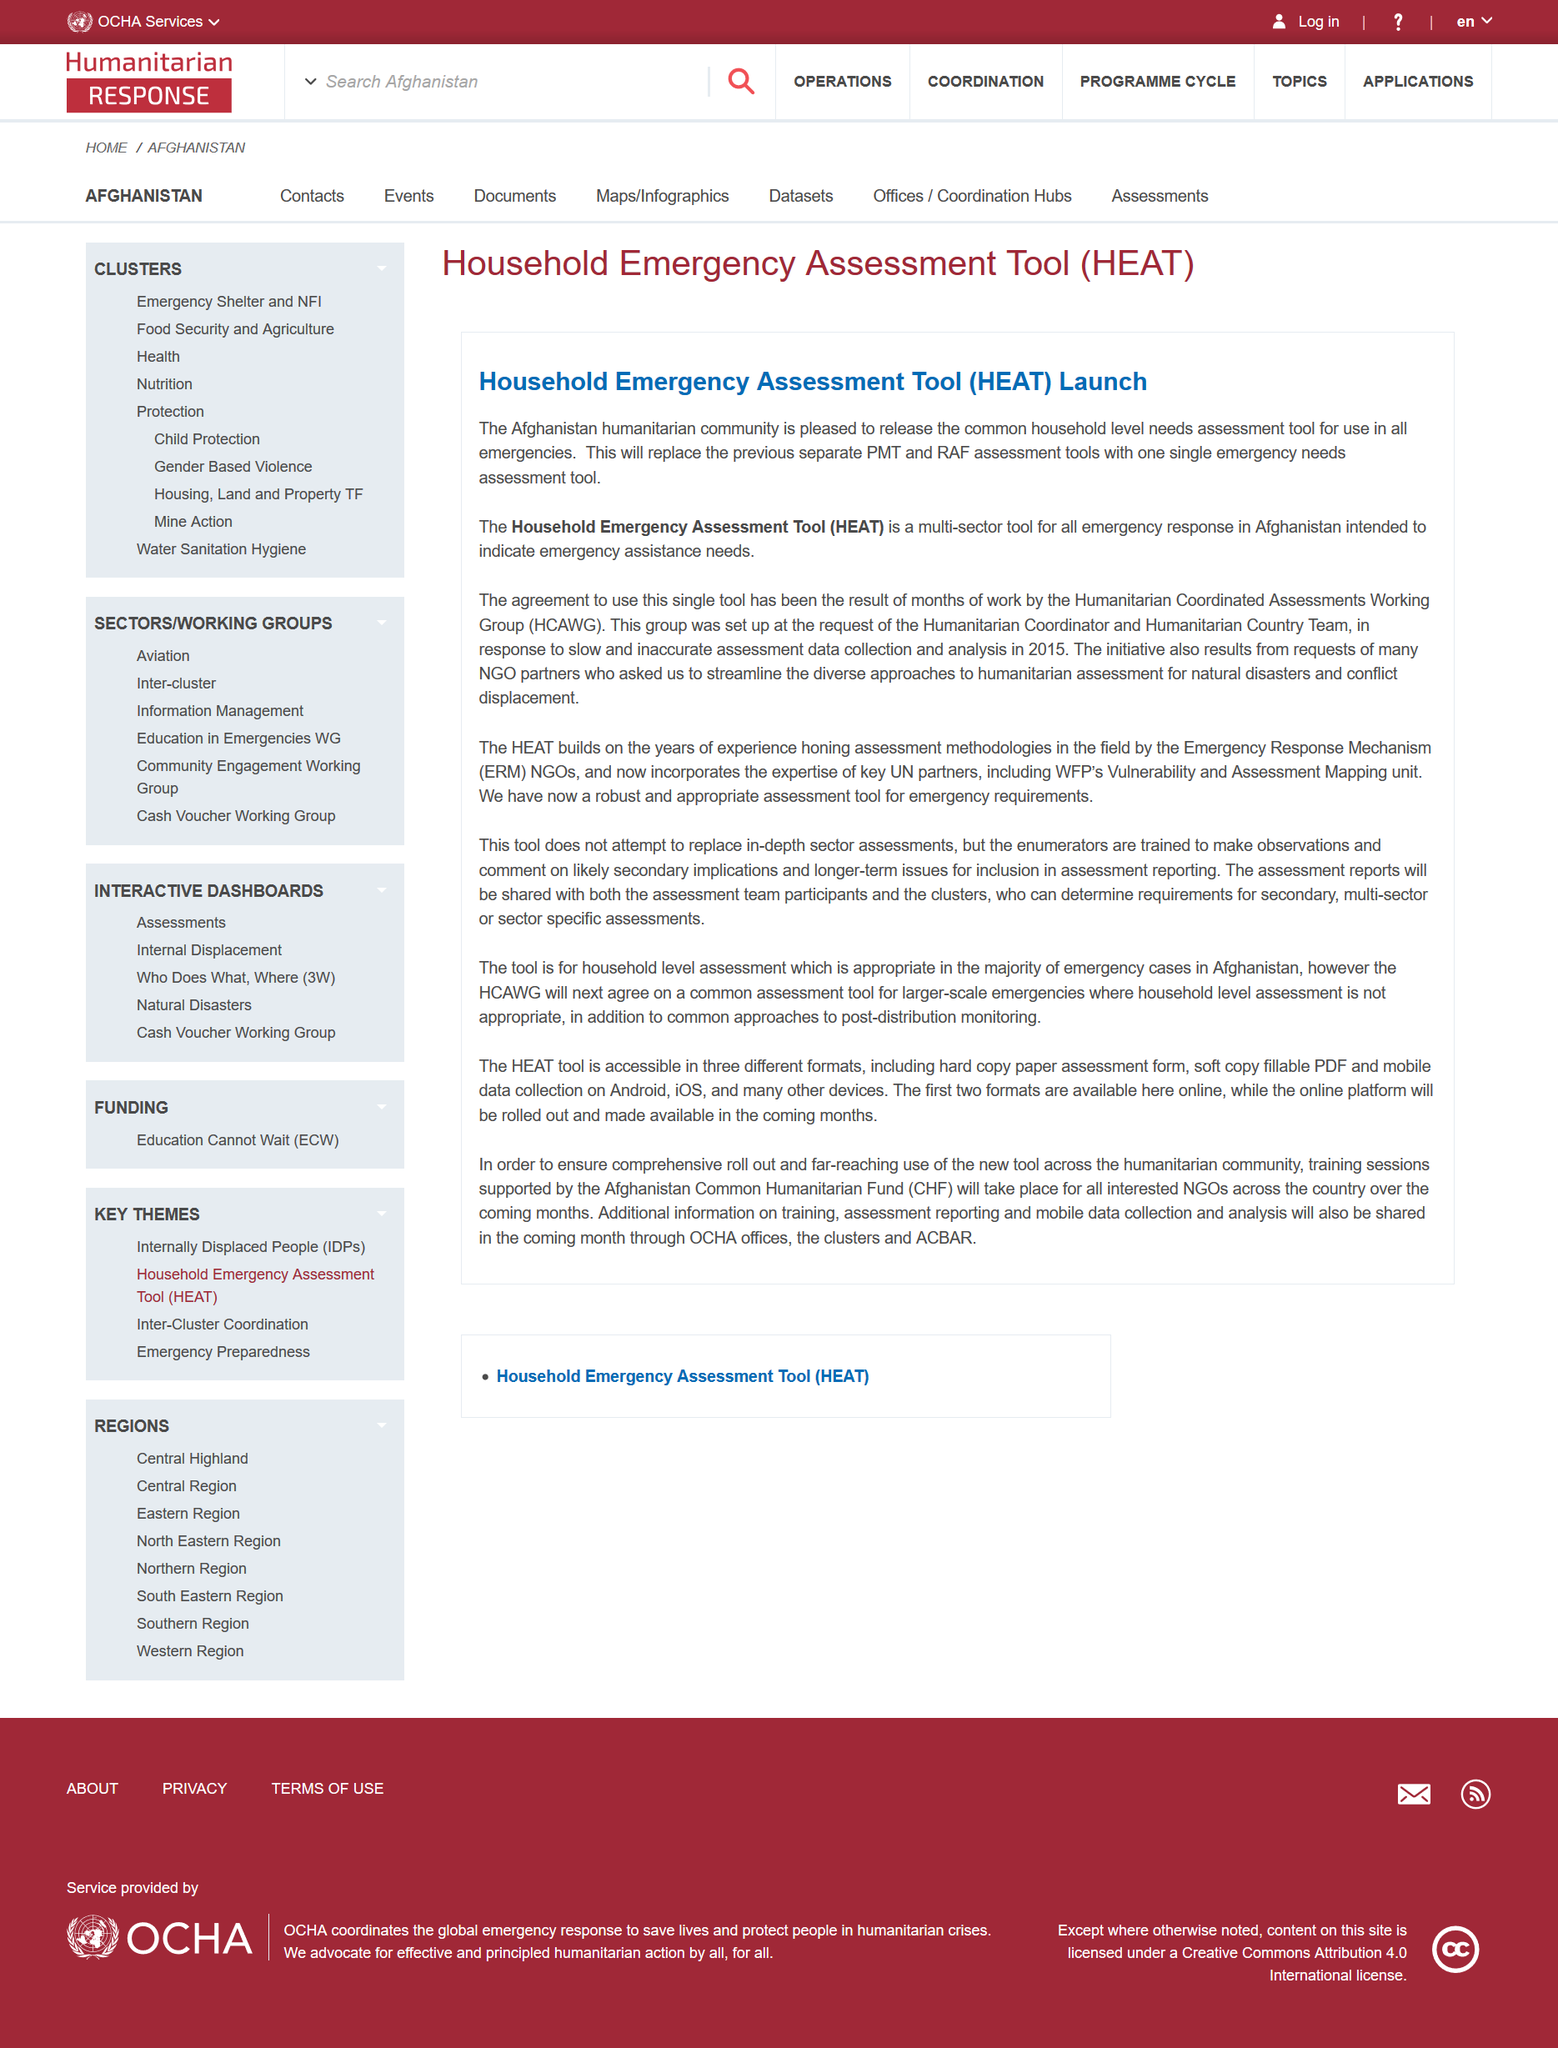Outline some significant characteristics in this image. The acronym "HEAT" stands for the Household Emergency Assessment Tool, a valuable resource for assessing and responding to emergencies within the home. The acronym HCAWG stands for Humanitarian Coordinated Assessments Working Group, which is a group that conducts assessments to address humanitarian needs. The introduction of HEAT marks the replacement of the previous PMT and RAF assessment tools, providing a more comprehensive and streamlined solution for assessing and analyzing data. 